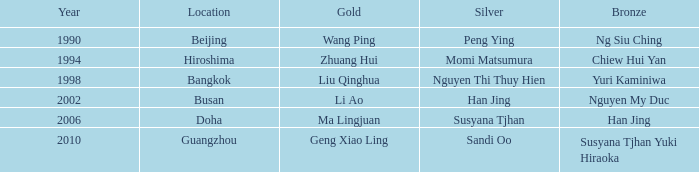What type of silver can be found in the guangzhou area? Sandi Oo. 